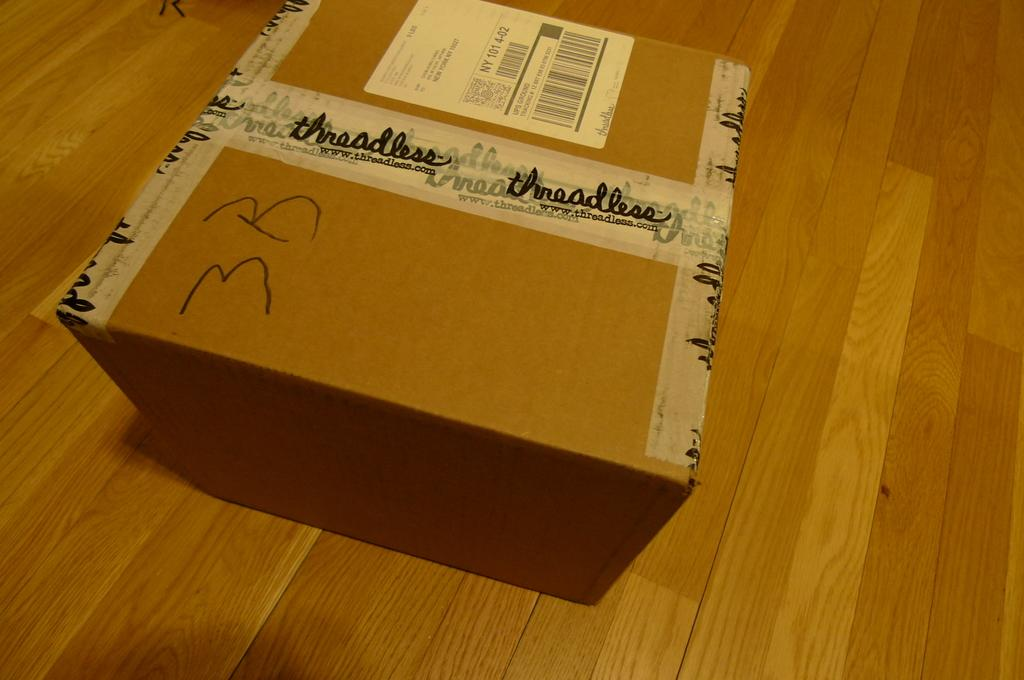What is the main subject in the center of the image? There is a cartoon box in the center of the image. What type of collar is visible on the cartoon box in the image? There is no collar present on the cartoon box in the image. 